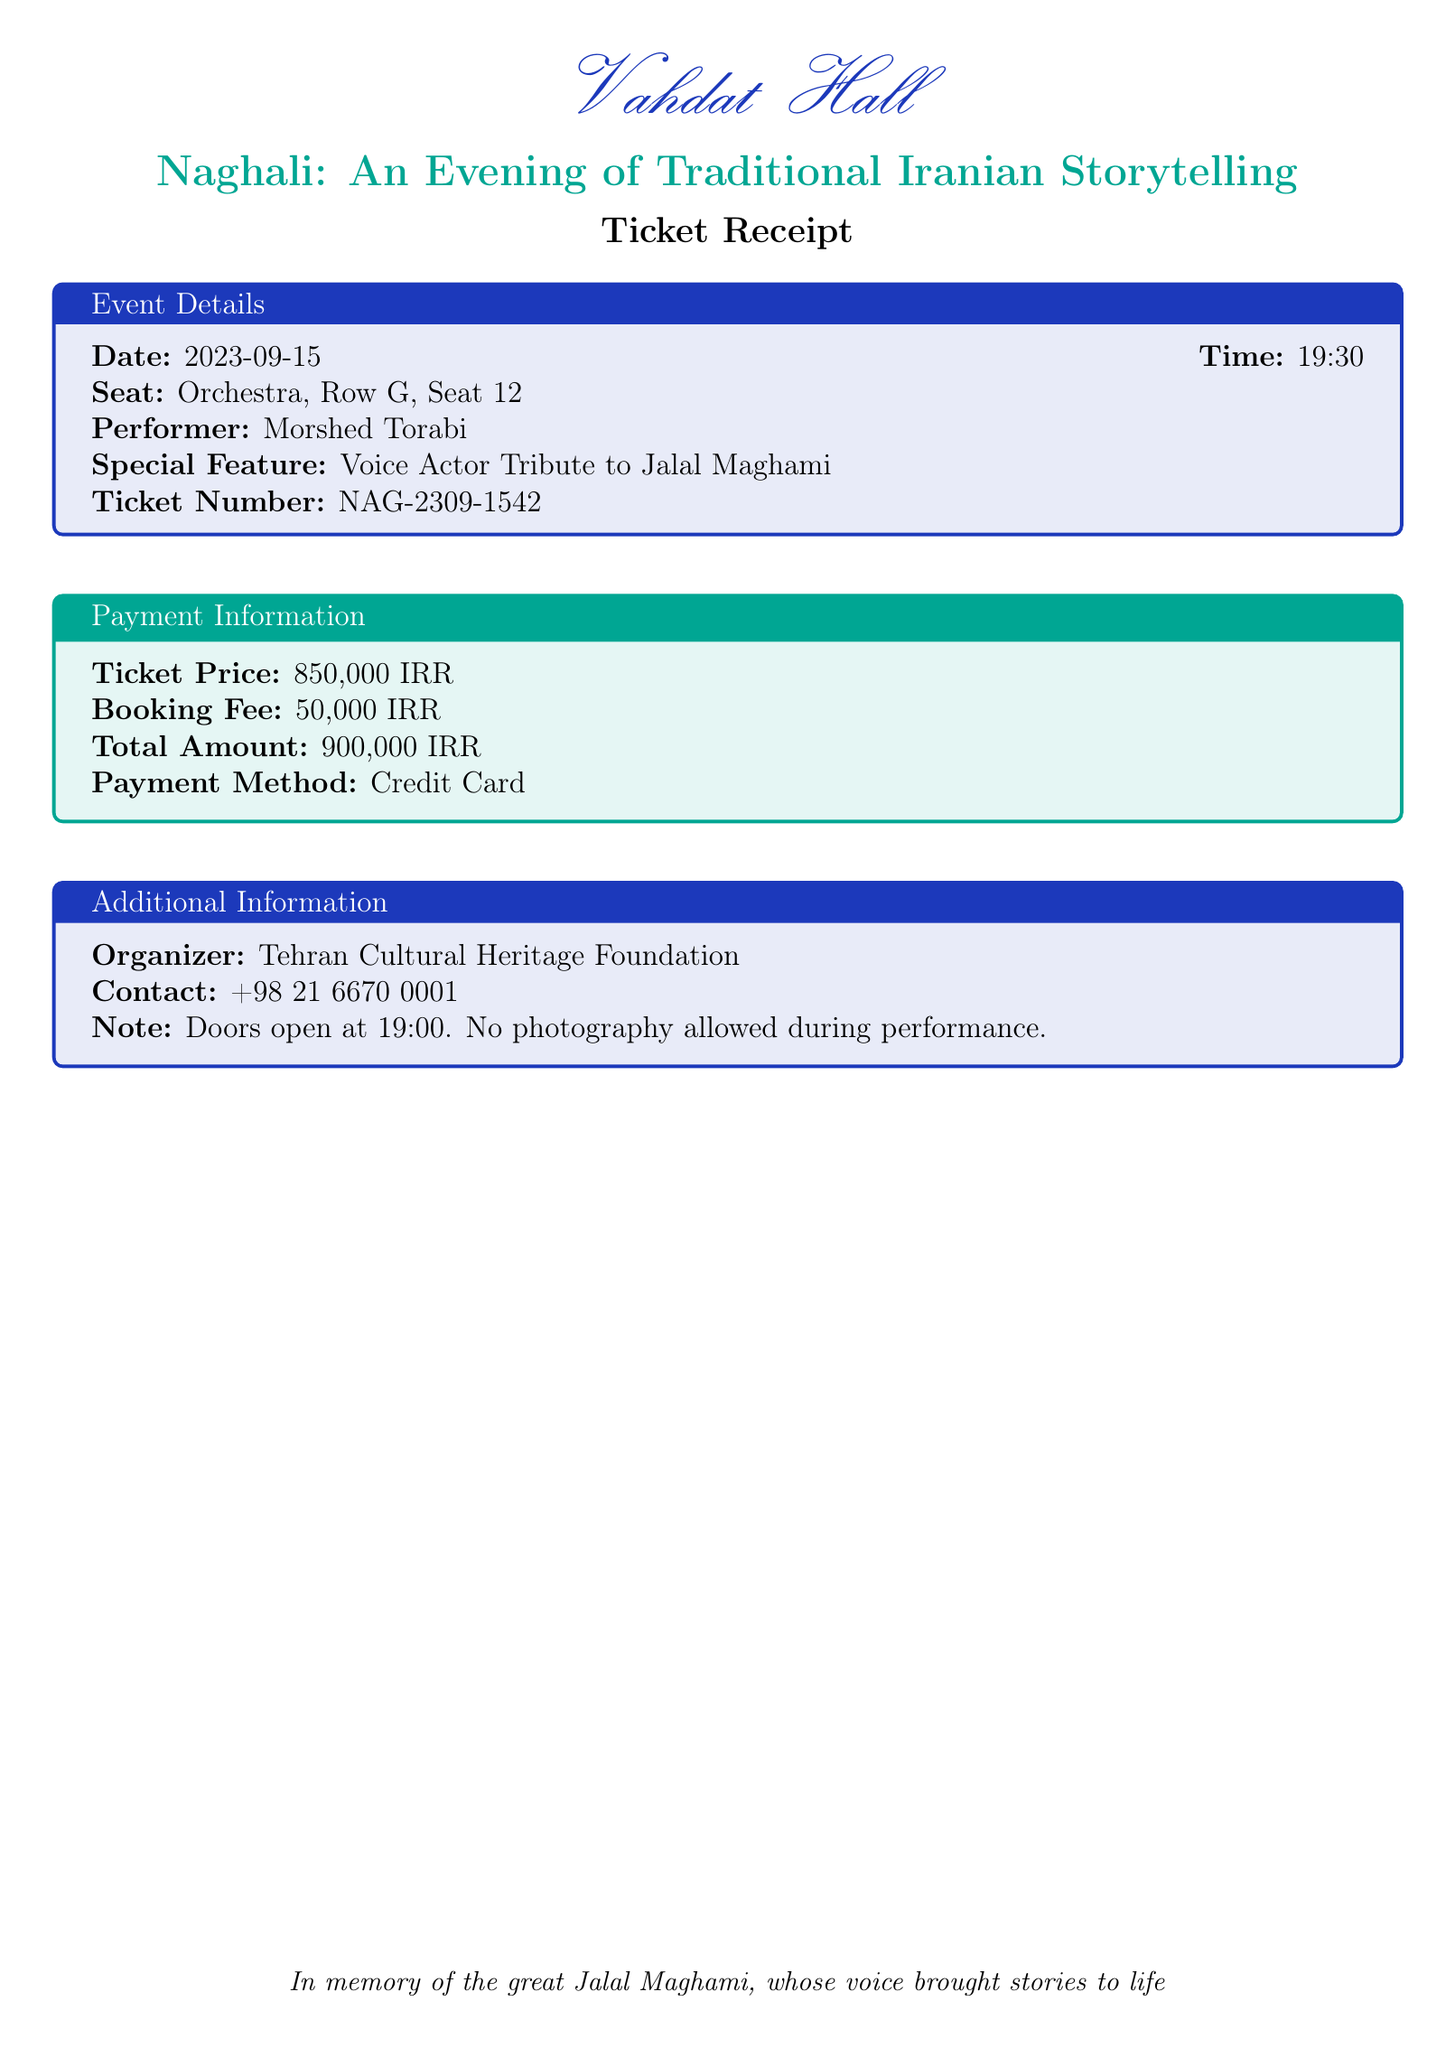What is the event date? The event date is specified in the document, which is 2023-09-15.
Answer: 2023-09-15 What is the ticket price? The ticket price is mentioned in the payment information section as 850,000 IRR.
Answer: 850,000 IRR Who is the performer? The performer is listed in the event details as Morshed Torabi.
Answer: Morshed Torabi What is the total amount charged? The total amount charged is provided in the payment information as 900,000 IRR.
Answer: 900,000 IRR What type of performance is featured? The type of performance is described in the title, which is Traditional Iranian Storytelling.
Answer: Traditional Iranian Storytelling What does the note about photography say? The note in the additional information states that no photography is allowed during the performance.
Answer: No photography allowed during performance Who organized the event? The organizer of the event is identified as Tehran Cultural Heritage Foundation.
Answer: Tehran Cultural Heritage Foundation At what time do the doors open? The doors opening time is specified in the additional information section as 19:00.
Answer: 19:00 What special feature is highlighted in the performance? The special feature mentioned is the Voice Actor Tribute to Jalal Maghami.
Answer: Voice Actor Tribute to Jalal Maghami 